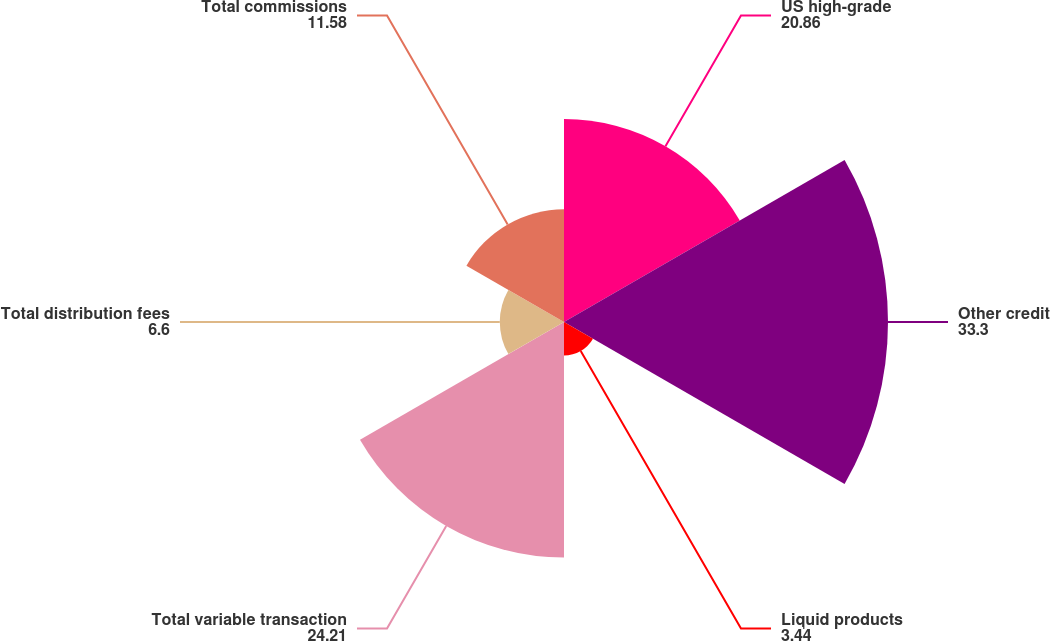<chart> <loc_0><loc_0><loc_500><loc_500><pie_chart><fcel>US high-grade<fcel>Other credit<fcel>Liquid products<fcel>Total variable transaction<fcel>Total distribution fees<fcel>Total commissions<nl><fcel>20.86%<fcel>33.3%<fcel>3.44%<fcel>24.21%<fcel>6.6%<fcel>11.58%<nl></chart> 